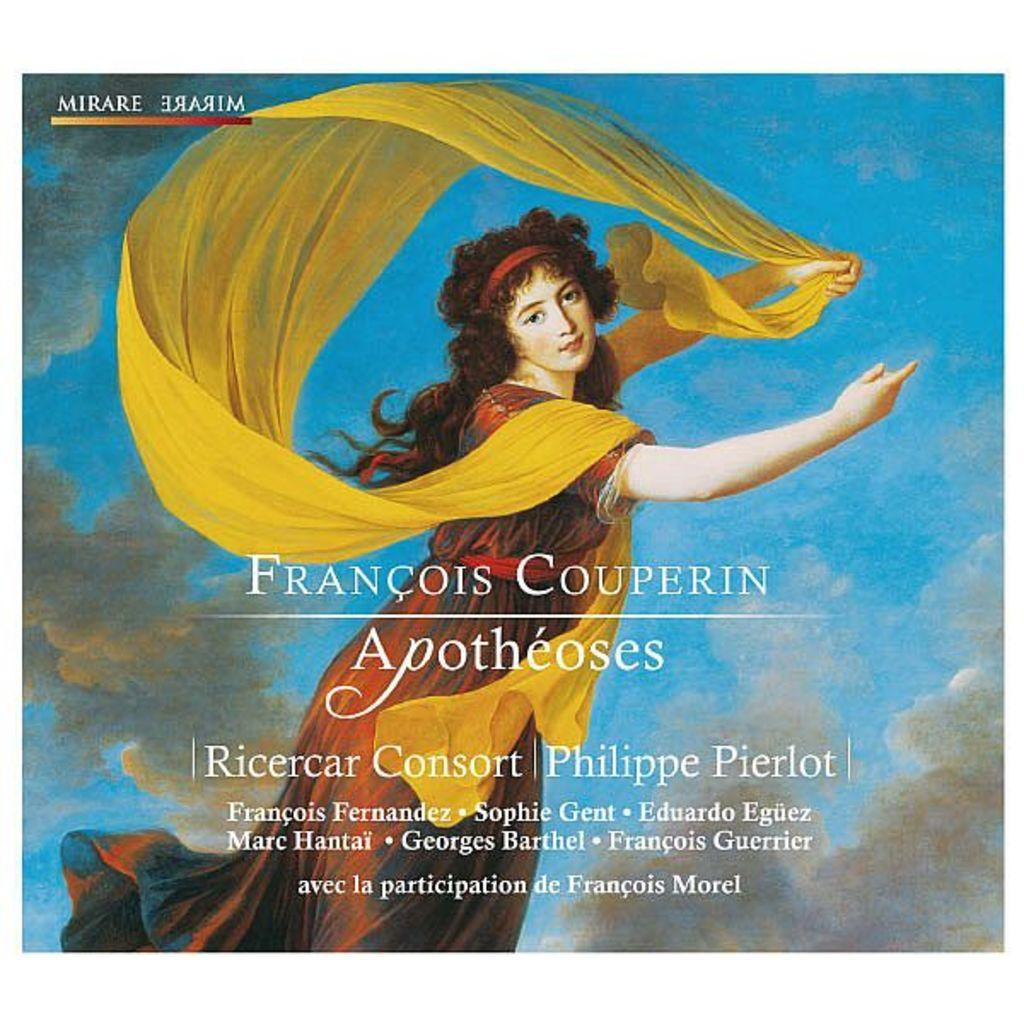Provide a one-sentence caption for the provided image. An album cover for Francois Couperin of a lady and a scarf. 